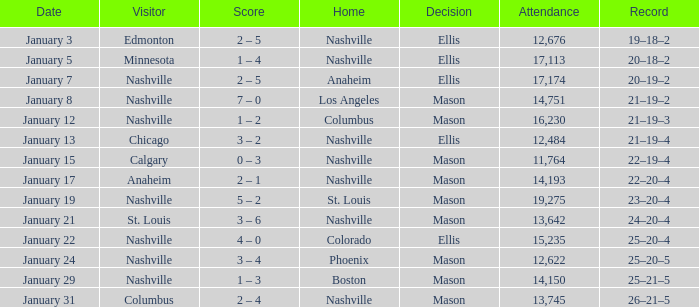On January 29, who had the decision of Mason? Nashville. 